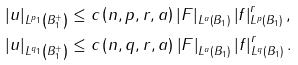Convert formula to latex. <formula><loc_0><loc_0><loc_500><loc_500>\left | u \right | _ { L ^ { p _ { 1 } } \left ( B _ { 1 } ^ { + } \right ) } & \leq c \left ( n , p , r , a \right ) \left | F \right | _ { L ^ { a } \left ( B _ { 1 } \right ) } \left | f \right | _ { L ^ { p } \left ( B _ { 1 } \right ) } ^ { r } , \\ \left | u \right | _ { L ^ { q _ { 1 } } \left ( B _ { 1 } ^ { + } \right ) } & \leq c \left ( n , q , r , a \right ) \left | F \right | _ { L ^ { a } \left ( B _ { 1 } \right ) } \left | f \right | _ { L ^ { q } \left ( B _ { 1 } \right ) } ^ { r } .</formula> 